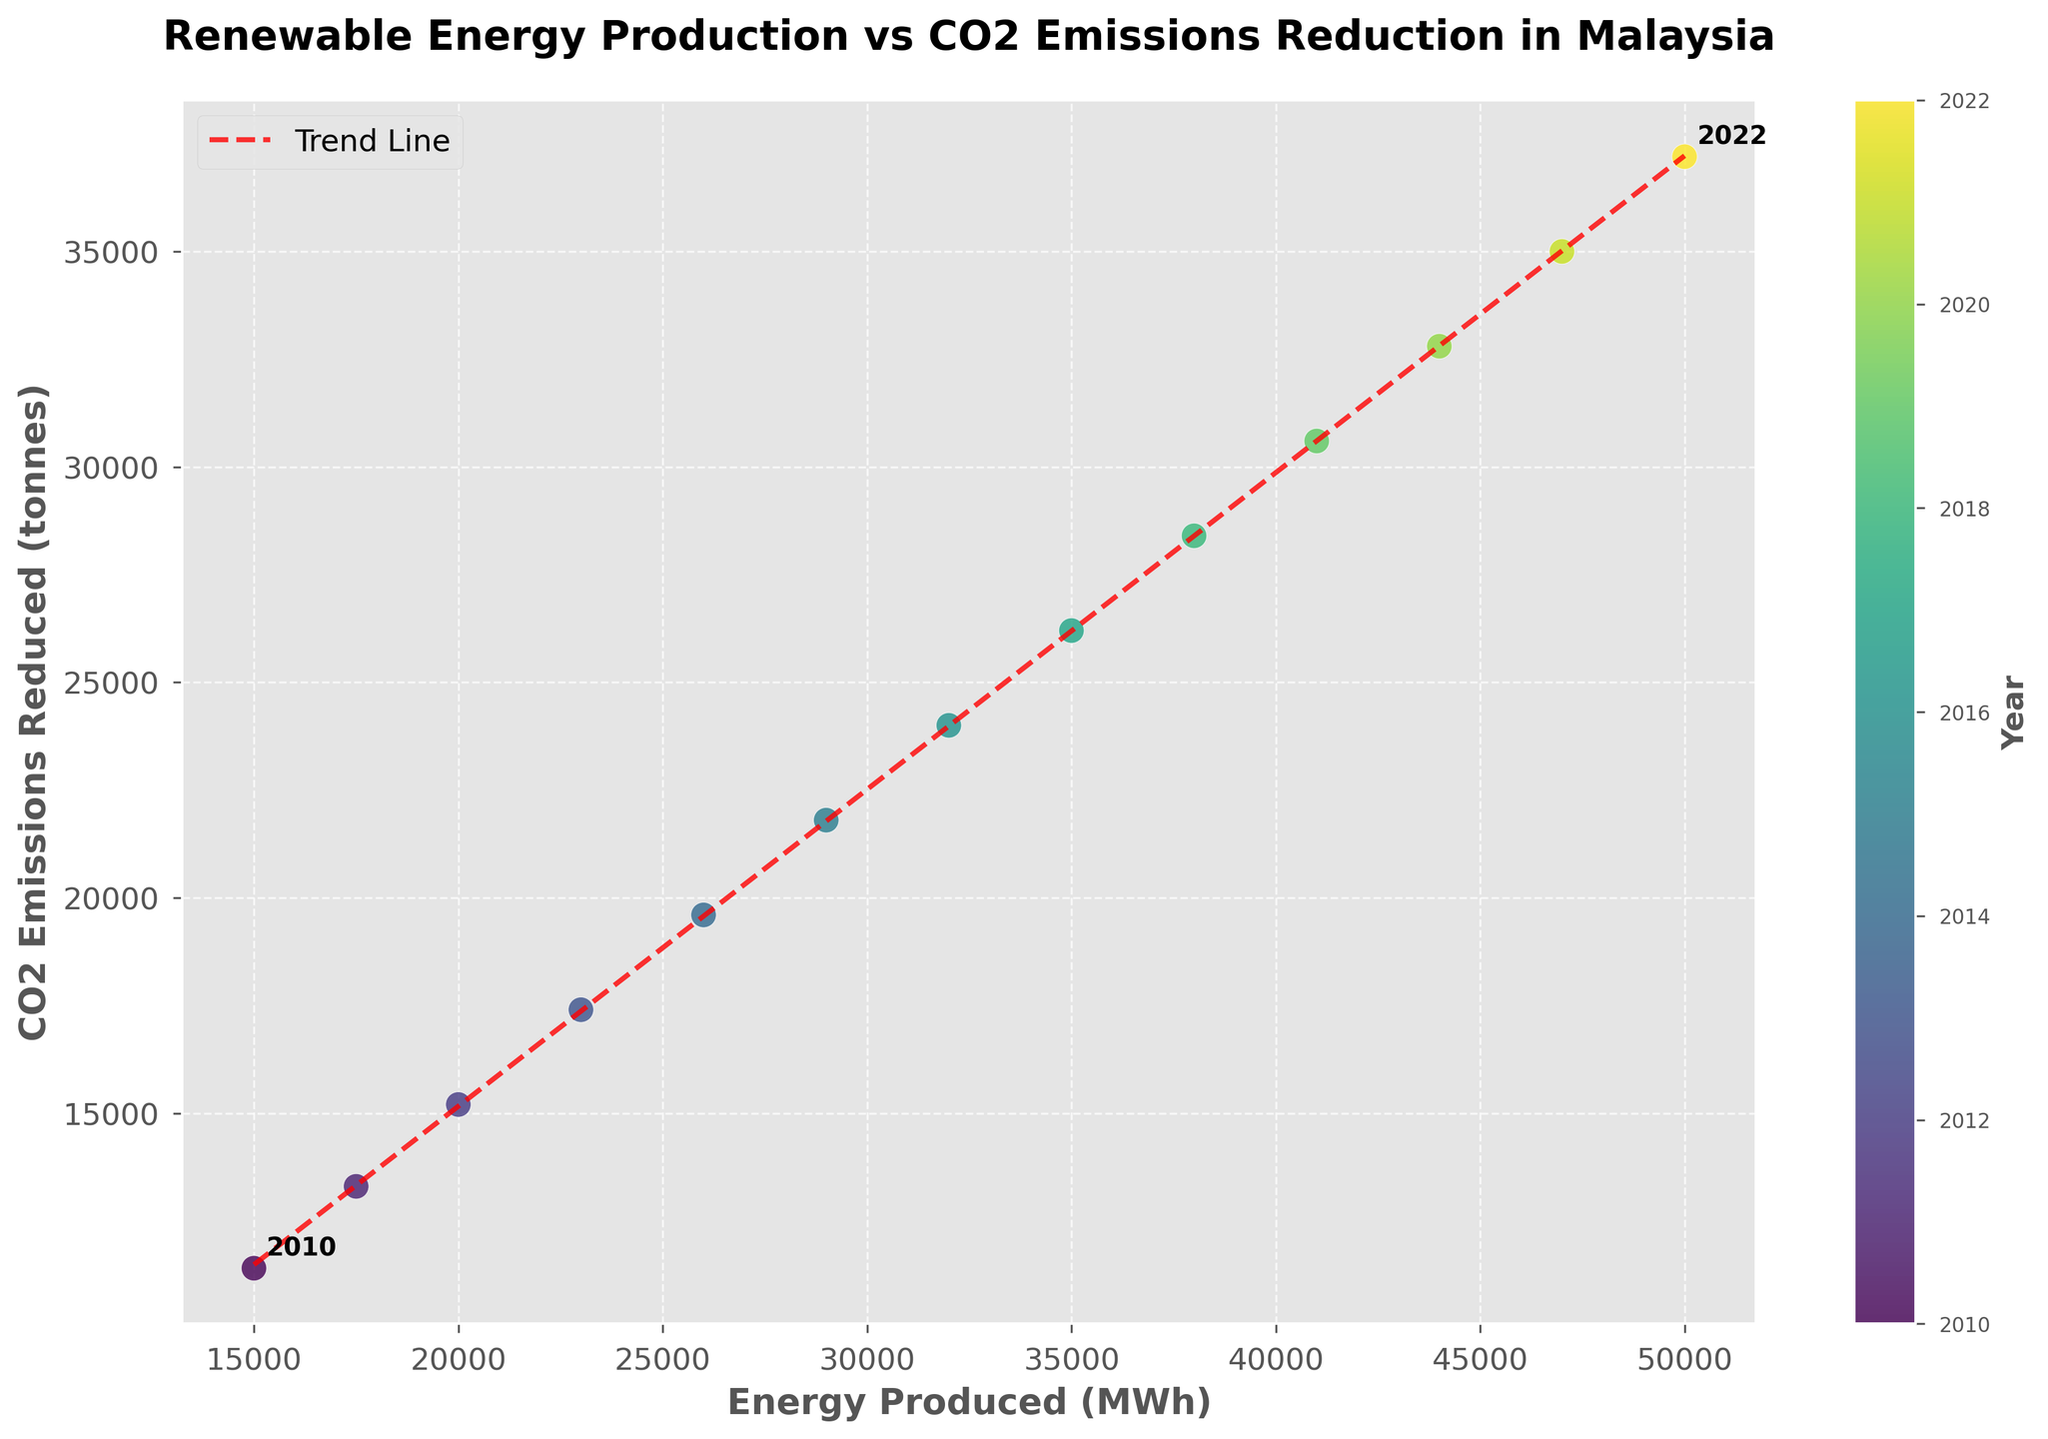What's the title of the figure? The title of the figure is displayed at the top of the chart. It reads "Renewable Energy Production vs CO2 Emissions Reduction in Malaysia".
Answer: Renewable Energy Production vs CO2 Emissions Reduction in Malaysia What are the units for 'Energy Produced' and 'CO2 Emissions Reduced' on the axes? The x-axis is labeled 'Energy Produced (MWh)' and the y-axis is labeled 'CO2 Emissions Reduced (tonnes)', indicating the units are MWh for energy produced and tonnes for CO2 emissions reduced.
Answer: MWh and tonnes How many data points are displayed in the scatter plot? Each year from 2010 to 2022 is represented by one data point. Counting the years, there are 13 data points.
Answer: 13 Which year corresponds to the highest value of 'Energy Produced'? By looking at the axis coordinates and corresponding color on the scatter plot, the highest 'Energy Produced' value (50000 MWh) corresponds to the year 2022.
Answer: 2022 What's the value of 'CO2 Emissions Reduced' in the year 2015? Locate the data point for the year 2015 on the color gradient, corresponding to 'Energy Produced' of 29000 MWh, then trace its position to the y-axis which shows 'CO2 Emissions Reduced' as 21800 tonnes.
Answer: 21800 tonnes Are there any years where the 'Energy Produced' and 'CO2 Emissions Reduced' values are equal? No years show equal 'Energy Produced' and 'CO2 Emissions Reduced' values, as all the energy values (in MWh) are numerically different from the emissions values (in tonnes).
Answer: No What is the overall trend between 'Energy Produced' and 'CO2 Emissions Reduced'? The scatter plot shows an increasing trend where higher energy production correlates with higher CO2 emissions reduction, as indicated by the upward trend line.
Answer: Positive correlation By how much did 'CO2 Emissions Reduced' increase between 2010 and 2022? The 'CO2 Emissions Reduced' for 2010 is 11400 tonnes, and for 2022, it is 37200 tonnes. The difference is 37200 - 11400 = 25800 tonnes.
Answer: 25800 tonnes Which year had an 'Energy Produced' value of 35000 MWh and what was the 'CO2 Emissions Reduced' for that year? The scatter point with 'Energy Produced' of 35000 MWh has a corresponding year of 2017. The 'CO2 Emissions Reduced' for that year is 26200 tonnes.
Answer: 2017, 26200 tonnes How does the trend line help in understanding the relationship between 'Energy Produced' and 'CO2 Emissions Reduced'? The trend line elucidates the positive linear relationship, illustrating that as 'Energy Produced' increases, 'CO2 Emissions Reduced' also tends to increase.
Answer: Shows positive linear relationship 